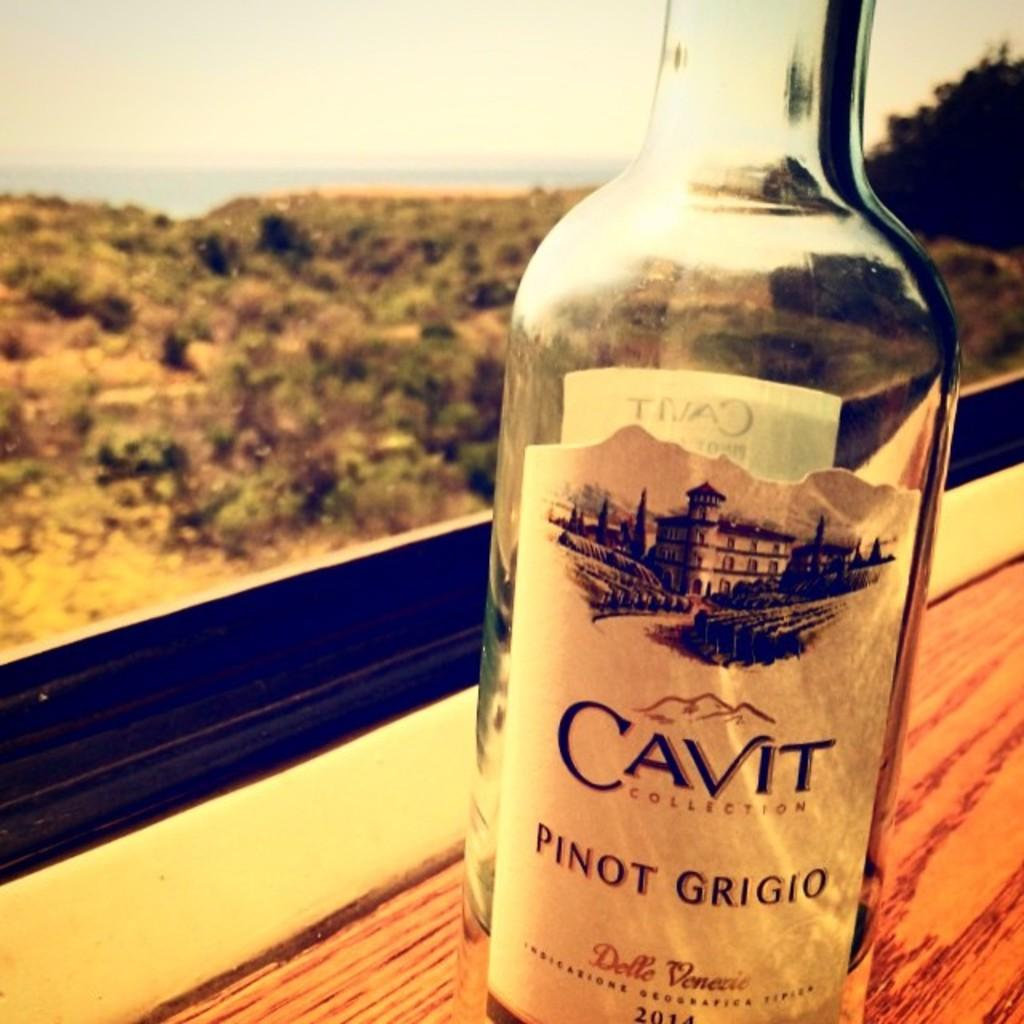<image>
Write a terse but informative summary of the picture. A bottle of Pinot Grigio is sitting on a ledge in front of a window. 